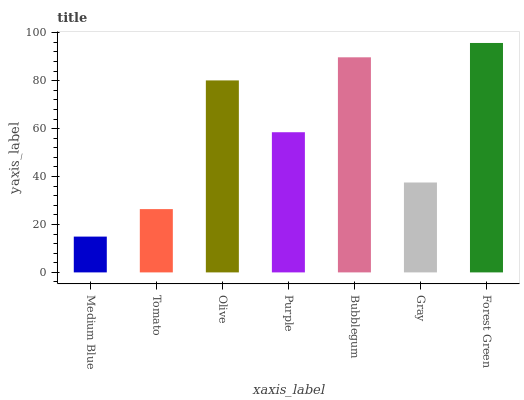Is Medium Blue the minimum?
Answer yes or no. Yes. Is Forest Green the maximum?
Answer yes or no. Yes. Is Tomato the minimum?
Answer yes or no. No. Is Tomato the maximum?
Answer yes or no. No. Is Tomato greater than Medium Blue?
Answer yes or no. Yes. Is Medium Blue less than Tomato?
Answer yes or no. Yes. Is Medium Blue greater than Tomato?
Answer yes or no. No. Is Tomato less than Medium Blue?
Answer yes or no. No. Is Purple the high median?
Answer yes or no. Yes. Is Purple the low median?
Answer yes or no. Yes. Is Bubblegum the high median?
Answer yes or no. No. Is Forest Green the low median?
Answer yes or no. No. 